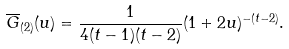Convert formula to latex. <formula><loc_0><loc_0><loc_500><loc_500>\overline { G } _ { ( 2 ) } ( u ) = \frac { 1 } { 4 ( t - 1 ) ( t - 2 ) } ( 1 + 2 u ) ^ { - ( t - 2 ) } .</formula> 